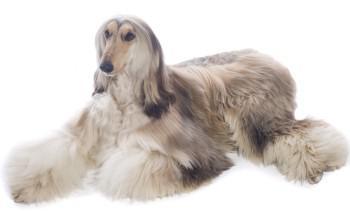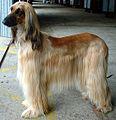The first image is the image on the left, the second image is the image on the right. Assess this claim about the two images: "An image shows a standing dog with a leash attached.". Correct or not? Answer yes or no. Yes. The first image is the image on the left, the second image is the image on the right. Considering the images on both sides, is "There is at least one dog standing on all fours in the image on the left." valid? Answer yes or no. No. 